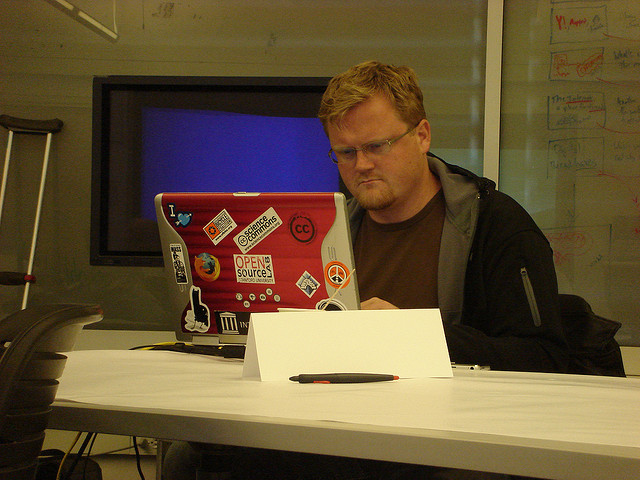Identify the text contained in this image. OPEN science common science commons CC source IN Y I LAB 